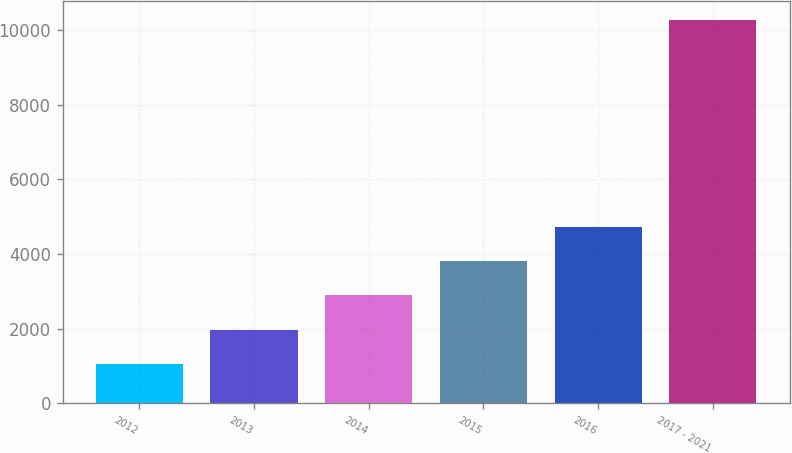Convert chart to OTSL. <chart><loc_0><loc_0><loc_500><loc_500><bar_chart><fcel>2012<fcel>2013<fcel>2014<fcel>2015<fcel>2016<fcel>2017 - 2021<nl><fcel>1052<fcel>1972.6<fcel>2893.2<fcel>3813.8<fcel>4734.4<fcel>10258<nl></chart> 